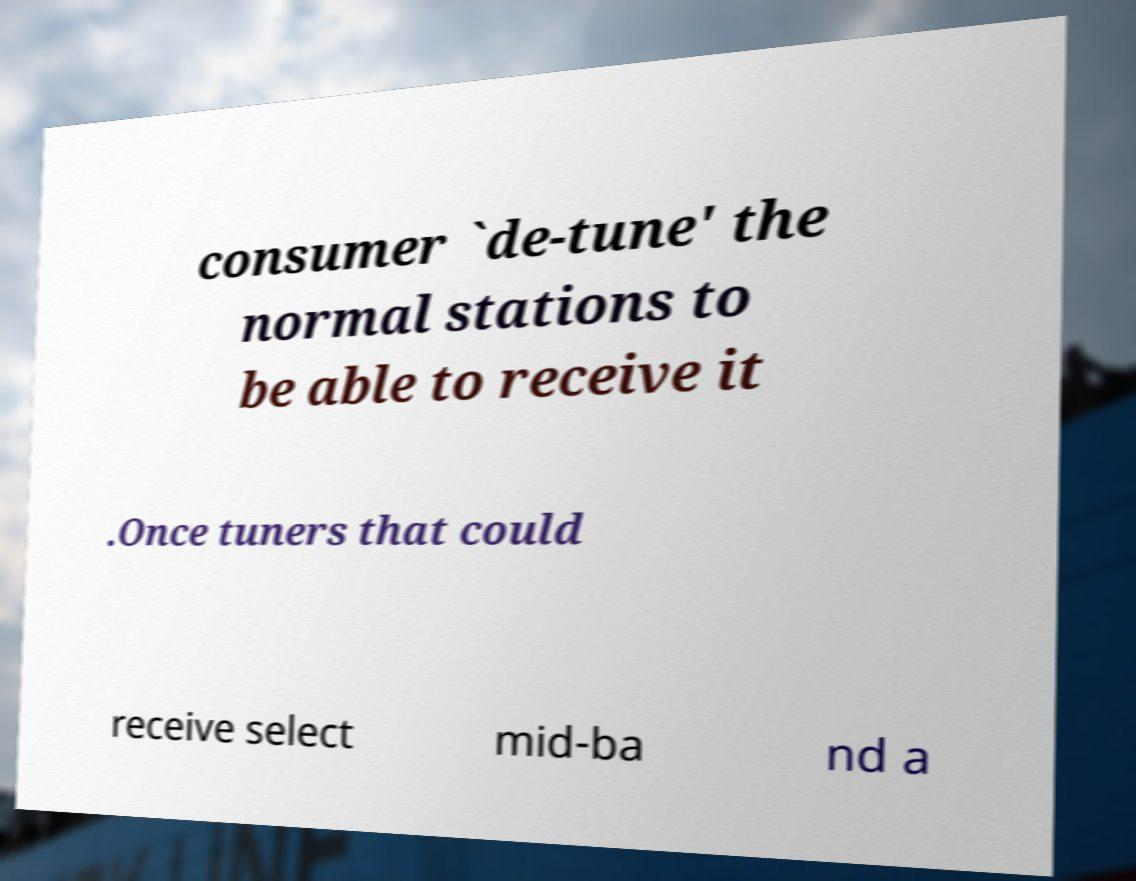There's text embedded in this image that I need extracted. Can you transcribe it verbatim? consumer `de-tune' the normal stations to be able to receive it .Once tuners that could receive select mid-ba nd a 